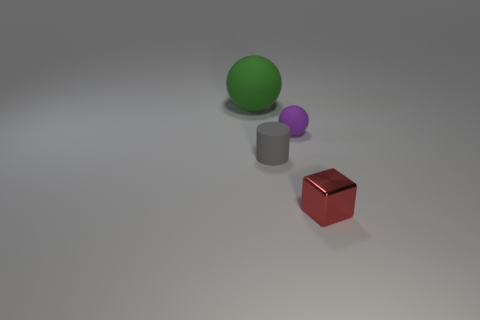What is the shape of the matte thing that is behind the gray rubber thing and to the right of the large object?
Your response must be concise. Sphere. Is the number of small red cubes behind the shiny object the same as the number of things that are to the left of the green ball?
Offer a very short reply. Yes. How many things are either tiny gray rubber cylinders or purple balls?
Give a very brief answer. 2. There is a cube that is the same size as the gray rubber thing; what color is it?
Provide a succinct answer. Red. How many objects are either purple things that are to the right of the small cylinder or small objects that are to the right of the tiny gray cylinder?
Provide a short and direct response. 2. Is the number of red metal cubes to the left of the shiny object the same as the number of yellow matte cylinders?
Keep it short and to the point. Yes. There is a thing that is to the right of the tiny rubber ball; is it the same size as the rubber ball right of the big rubber thing?
Offer a very short reply. Yes. How many other things are the same size as the metallic thing?
Offer a terse response. 2. Is there a gray cylinder that is right of the rubber object that is on the left side of the small matte object on the left side of the small purple thing?
Your response must be concise. Yes. Is there any other thing that is the same color as the small metal cube?
Offer a terse response. No. 